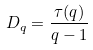Convert formula to latex. <formula><loc_0><loc_0><loc_500><loc_500>D _ { q } = \frac { \tau ( q ) } { q - 1 }</formula> 